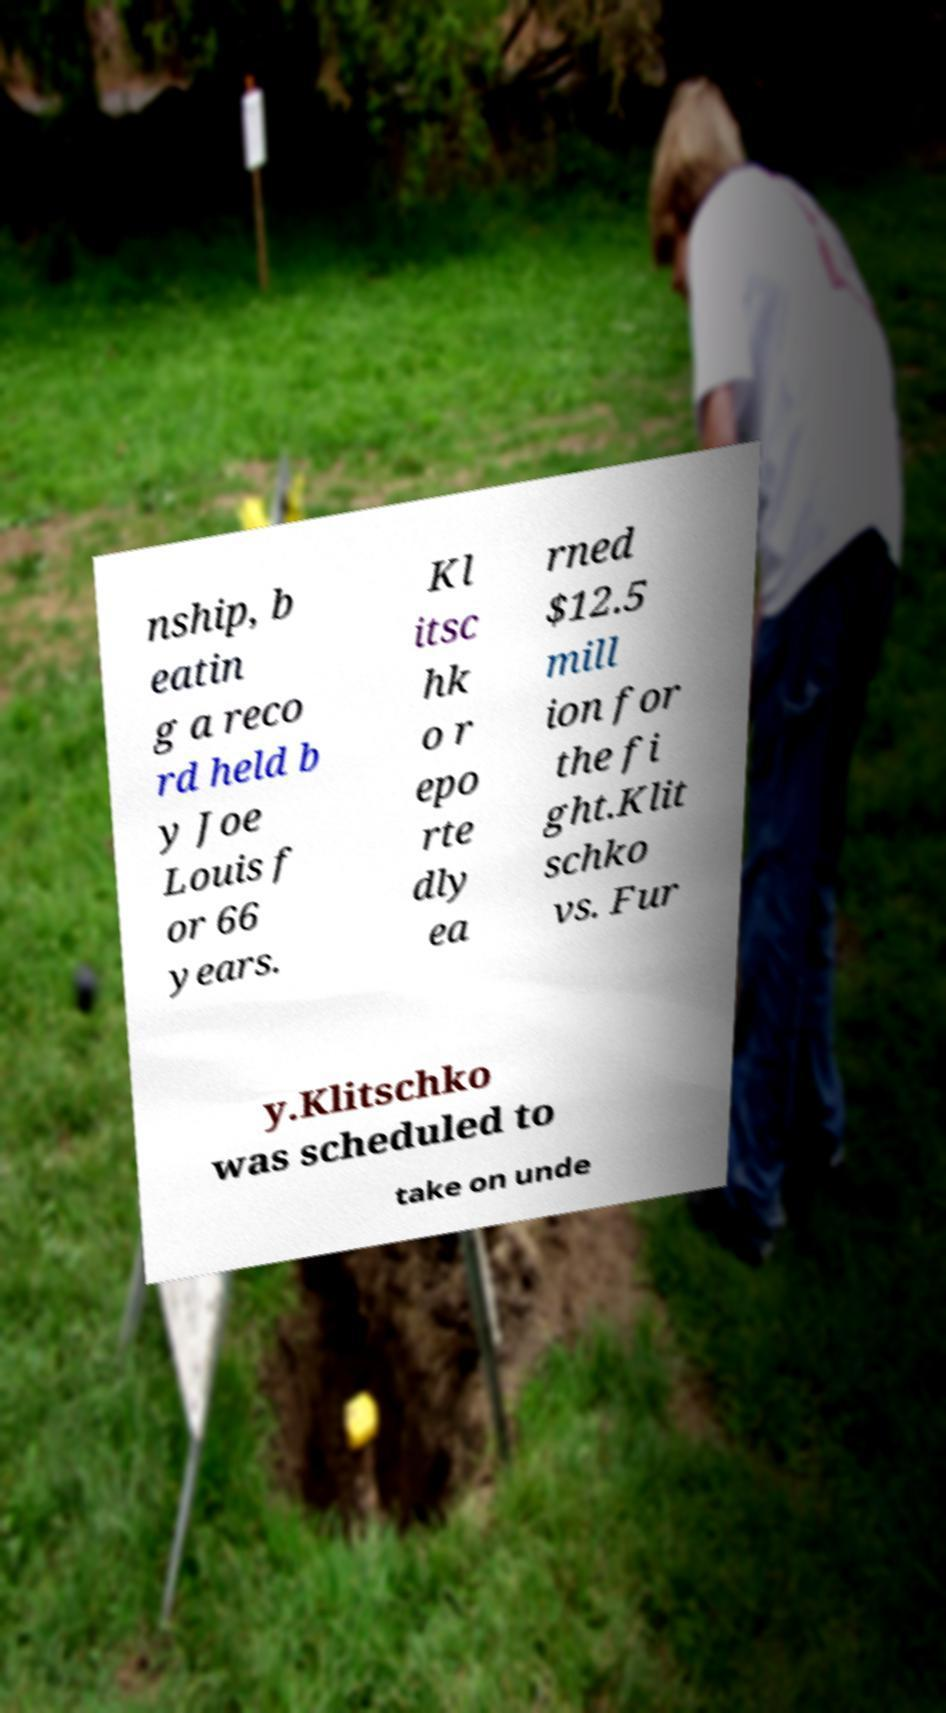Can you accurately transcribe the text from the provided image for me? nship, b eatin g a reco rd held b y Joe Louis f or 66 years. Kl itsc hk o r epo rte dly ea rned $12.5 mill ion for the fi ght.Klit schko vs. Fur y.Klitschko was scheduled to take on unde 